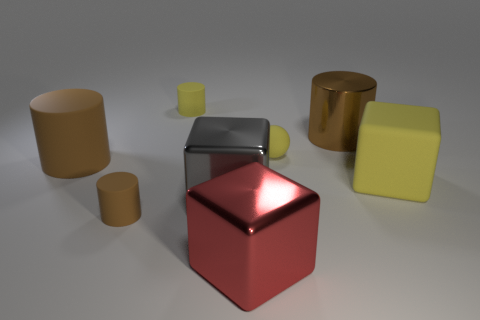Subtract all cyan cubes. How many brown cylinders are left? 3 Subtract 1 cylinders. How many cylinders are left? 3 Add 2 big red metal balls. How many objects exist? 10 Subtract all cubes. How many objects are left? 5 Subtract all tiny blue shiny cylinders. Subtract all brown shiny cylinders. How many objects are left? 7 Add 6 big brown cylinders. How many big brown cylinders are left? 8 Add 5 tiny brown rubber cylinders. How many tiny brown rubber cylinders exist? 6 Subtract 0 red cylinders. How many objects are left? 8 